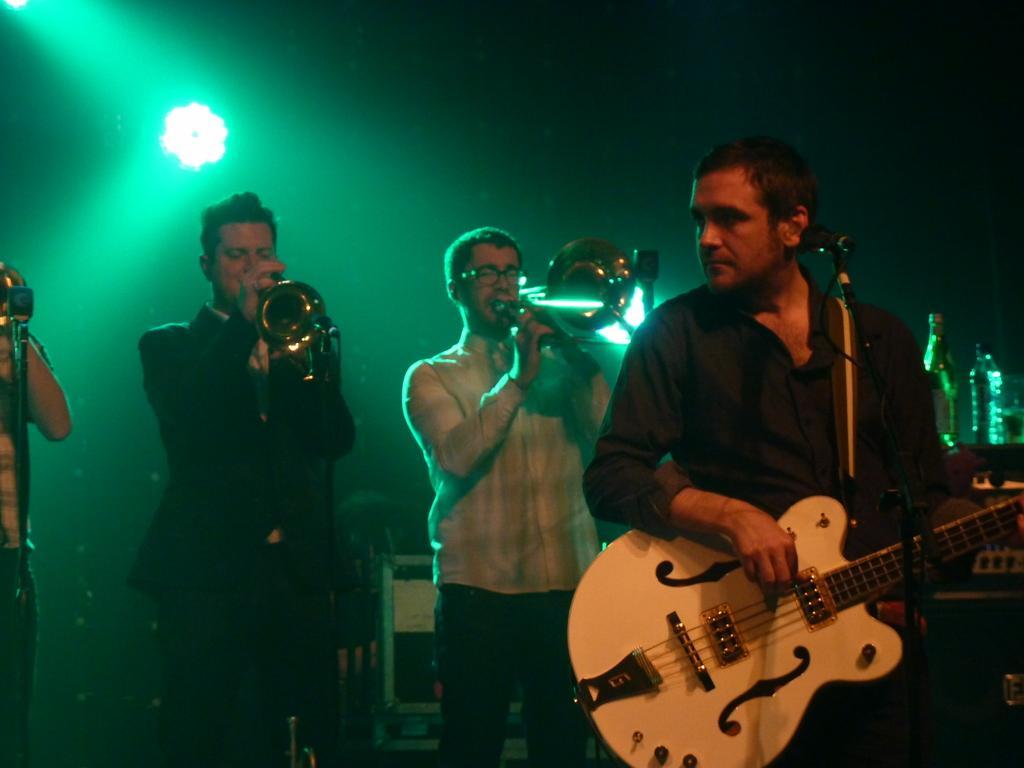Could you give a brief overview of what you see in this image? This is a picture of a live concert. On the right there is a man in black shirt playing guitar. In the center a man is playing trampoline. In the left there is another man in black suit playing trampoline. On the left a person is standing. background is dark there is a focus light. On the right there are two water bottles. On the right there is a microphone. 